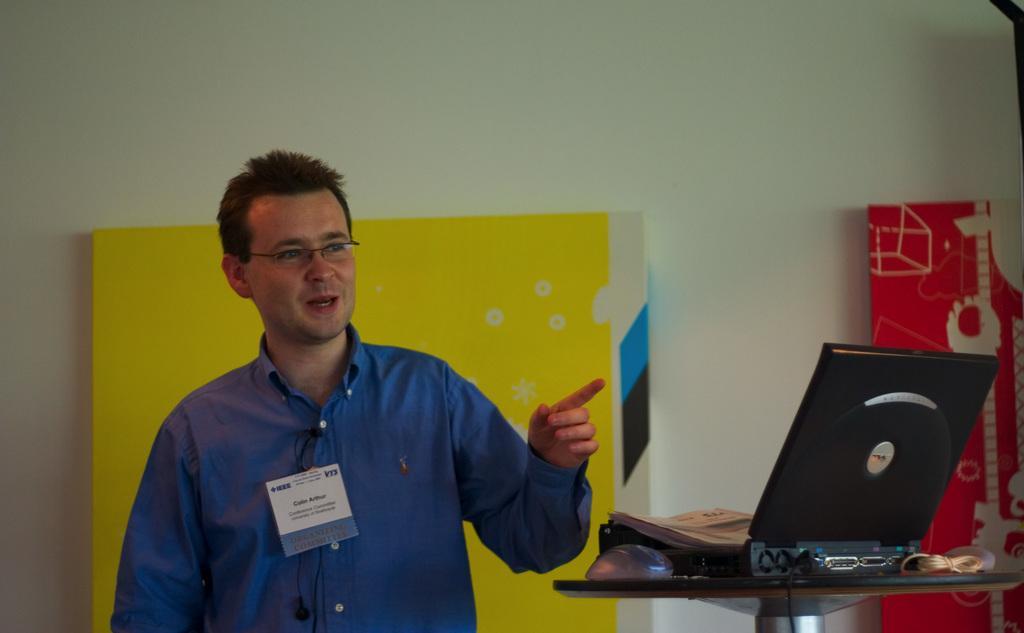Describe this image in one or two sentences. In this picture I can see a laptop and a mouse on the table and looks like few papers on the laptop and I can see a man standing and he is wearing spectacles and I can see couple of boards in the back and I can see wall. 